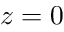Convert formula to latex. <formula><loc_0><loc_0><loc_500><loc_500>z = 0</formula> 